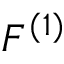<formula> <loc_0><loc_0><loc_500><loc_500>F ^ { ( 1 ) }</formula> 